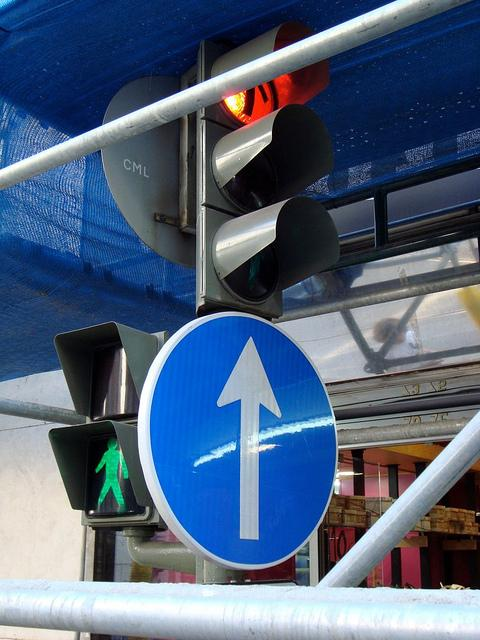What does the blue sign with a white arrow mean?

Choices:
A) ahead only
B) parking
C) stop
D) no turns ahead only 